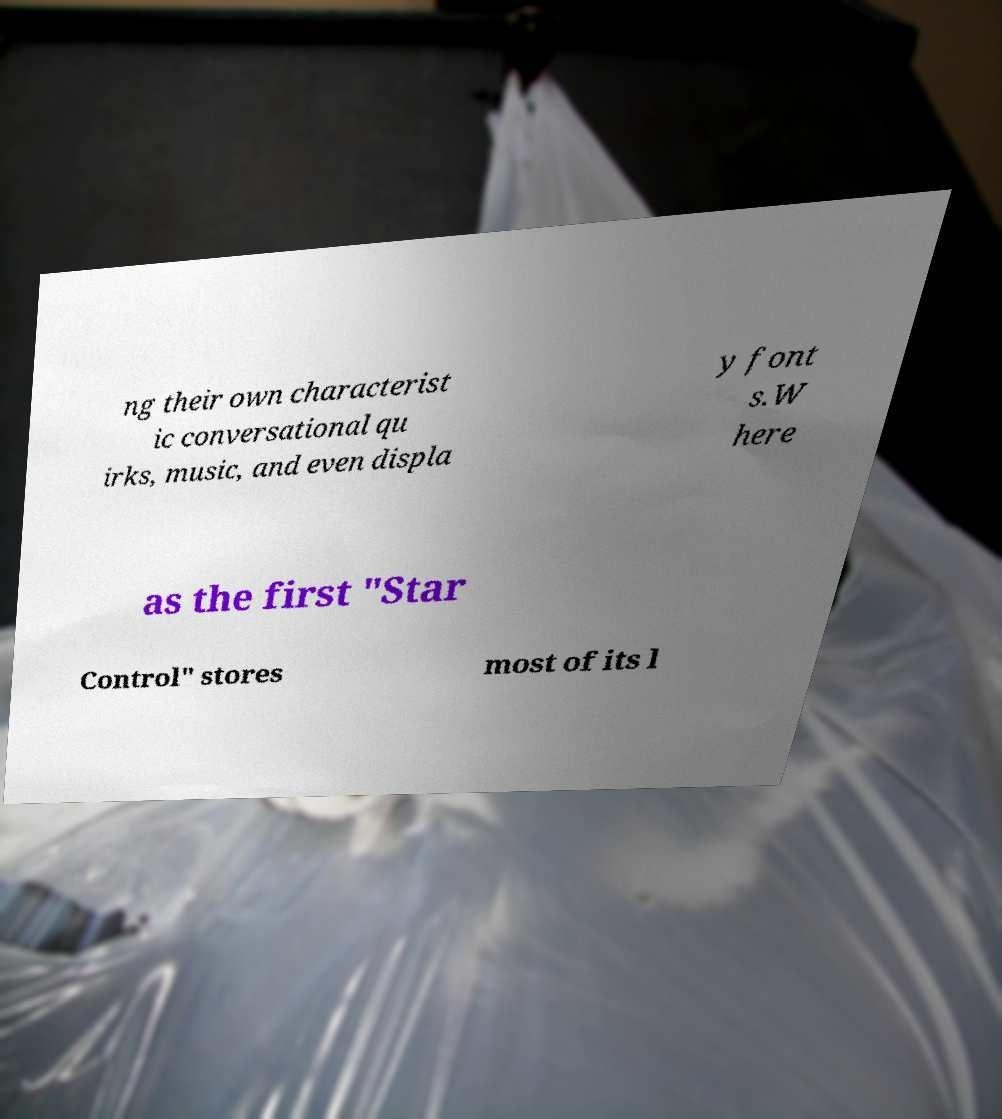Could you assist in decoding the text presented in this image and type it out clearly? ng their own characterist ic conversational qu irks, music, and even displa y font s.W here as the first "Star Control" stores most of its l 